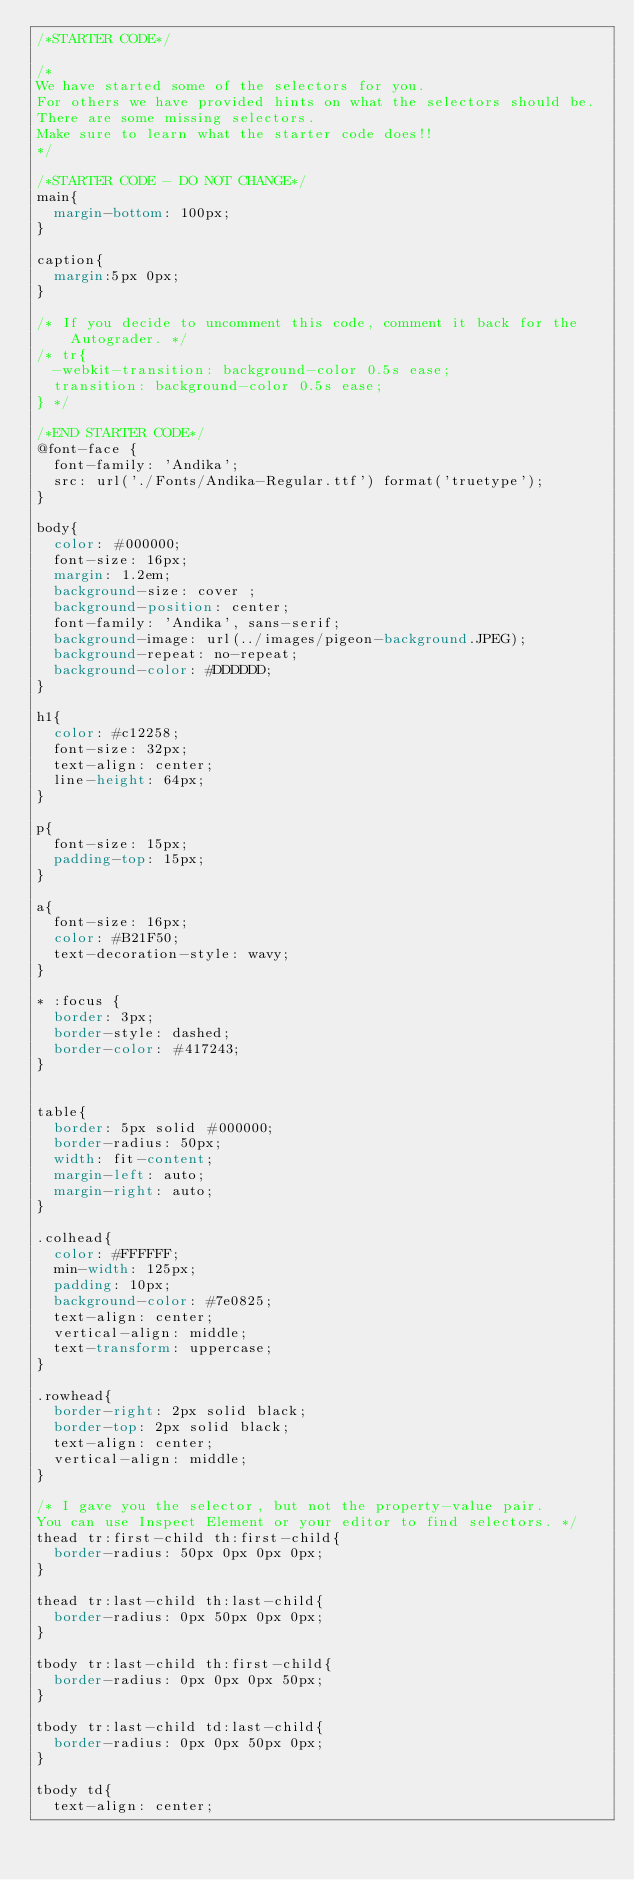<code> <loc_0><loc_0><loc_500><loc_500><_CSS_>/*STARTER CODE*/

/*
We have started some of the selectors for you.
For others we have provided hints on what the selectors should be.
There are some missing selectors.
Make sure to learn what the starter code does!!
*/

/*STARTER CODE - DO NOT CHANGE*/
main{
  margin-bottom: 100px;
}

caption{
  margin:5px 0px;
}

/* If you decide to uncomment this code, comment it back for the Autograder. */
/* tr{
  -webkit-transition: background-color 0.5s ease;
  transition: background-color 0.5s ease;
} */

/*END STARTER CODE*/
@font-face {
  font-family: 'Andika';
  src: url('./Fonts/Andika-Regular.ttf') format('truetype');
}

body{
  color: #000000;
  font-size: 16px;
  margin: 1.2em;
  background-size: cover ;
  background-position: center;
  font-family: 'Andika', sans-serif;
  background-image: url(../images/pigeon-background.JPEG);
  background-repeat: no-repeat;
  background-color: #DDDDDD;
}

h1{
  color: #c12258;
  font-size: 32px;
  text-align: center;
  line-height: 64px;
}

p{
  font-size: 15px;
  padding-top: 15px;
}

a{
  font-size: 16px;
  color: #B21F50;
  text-decoration-style: wavy;
}

* :focus {
  border: 3px;
  border-style: dashed;
  border-color: #417243;
}


table{
  border: 5px solid #000000;
  border-radius: 50px;
  width: fit-content;
  margin-left: auto;
  margin-right: auto;
}

.colhead{
  color: #FFFFFF;
  min-width: 125px;
  padding: 10px;
  background-color: #7e0825;
  text-align: center;
  vertical-align: middle;
  text-transform: uppercase;
}

.rowhead{
  border-right: 2px solid black;
  border-top: 2px solid black;
  text-align: center;
  vertical-align: middle;
}

/* I gave you the selector, but not the property-value pair. 
You can use Inspect Element or your editor to find selectors. */
thead tr:first-child th:first-child{
  border-radius: 50px 0px 0px 0px;
}

thead tr:last-child th:last-child{
  border-radius: 0px 50px 0px 0px;
}

tbody tr:last-child th:first-child{
  border-radius: 0px 0px 0px 50px;
}

tbody tr:last-child td:last-child{
  border-radius: 0px 0px 50px 0px;
}

tbody td{
  text-align: center;</code> 